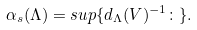Convert formula to latex. <formula><loc_0><loc_0><loc_500><loc_500>\alpha _ { s } ( \Lambda ) = s u p \{ d _ { \Lambda } ( V ) ^ { - 1 } \colon \} .</formula> 